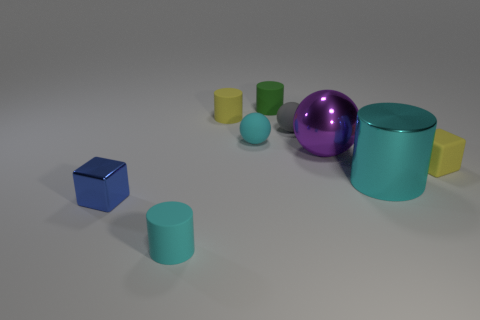There is a metal thing that is behind the tiny yellow thing that is in front of the large ball; what is its size?
Make the answer very short. Large. Is the number of small blue shiny blocks greater than the number of big yellow shiny cylinders?
Offer a terse response. Yes. Does the cyan rubber thing behind the cyan shiny cylinder have the same size as the small gray sphere?
Provide a succinct answer. Yes. What number of small cubes are the same color as the large metal cylinder?
Make the answer very short. 0. Does the tiny green thing have the same shape as the tiny blue shiny object?
Provide a succinct answer. No. Is there any other thing that is the same size as the gray ball?
Your response must be concise. Yes. There is a yellow rubber object that is the same shape as the tiny green rubber object; what is its size?
Your answer should be very brief. Small. Is the number of small balls in front of the large shiny cylinder greater than the number of small yellow blocks that are behind the shiny sphere?
Provide a short and direct response. No. Do the big cyan object and the tiny block that is on the left side of the yellow matte block have the same material?
Provide a short and direct response. Yes. Is there any other thing that has the same shape as the tiny blue shiny thing?
Make the answer very short. Yes. 